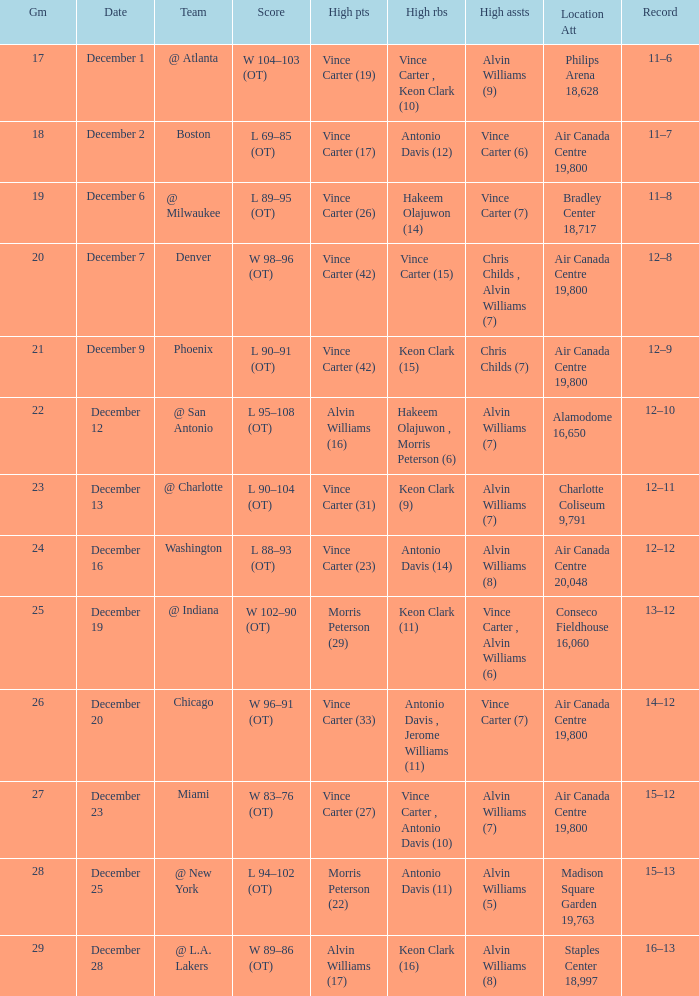What game happened on December 19? 25.0. 